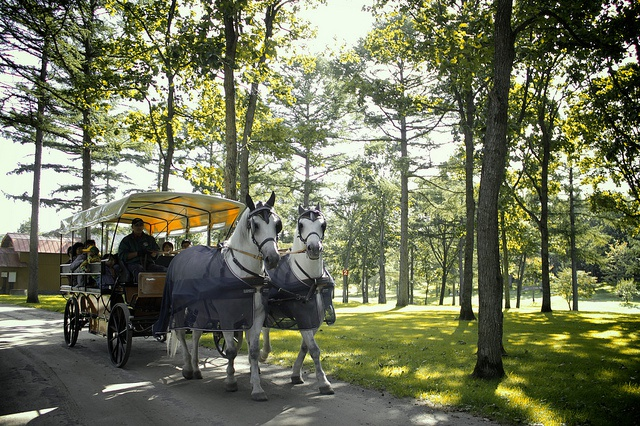Describe the objects in this image and their specific colors. I can see horse in darkgreen, black, gray, and darkgray tones, horse in darkgreen, black, gray, and darkgray tones, people in darkgreen, black, gray, and olive tones, people in darkgreen, black, and gray tones, and people in darkgreen, black, and gray tones in this image. 